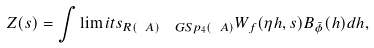<formula> <loc_0><loc_0><loc_500><loc_500>Z ( s ) = \int \lim i t s _ { R ( \ A ) \ \ G S p _ { 4 } ( \ A ) } W _ { f } ( \eta h , s ) B _ { \bar { \phi } } ( h ) d h ,</formula> 